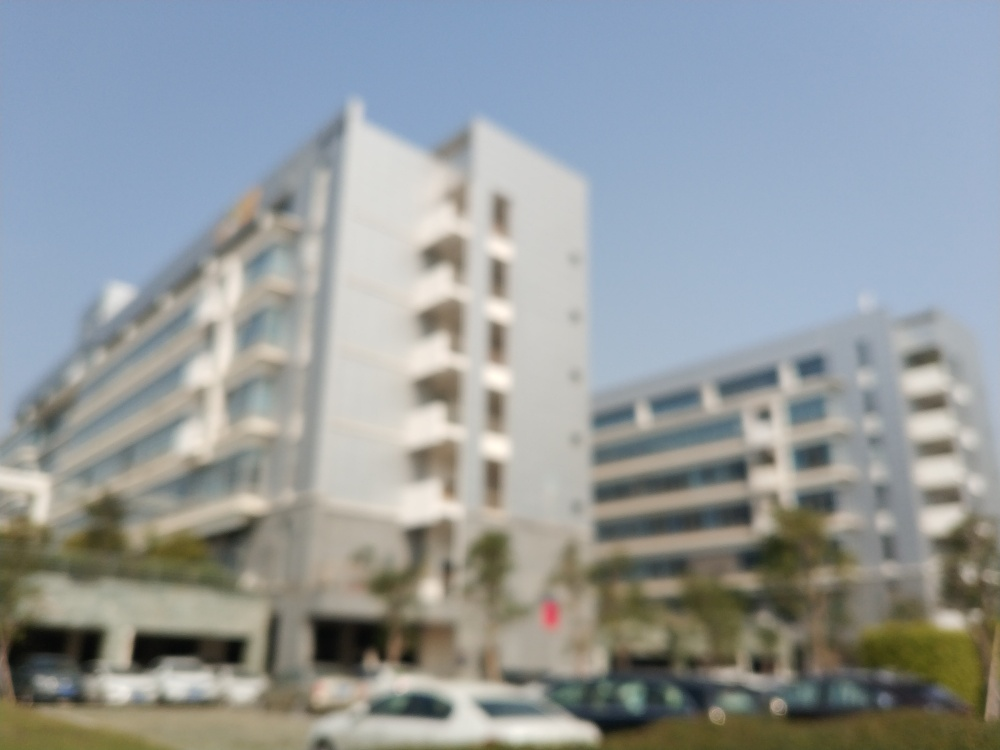What might be the reason for the blur in this image? The blur in the image could be due to several factors: a camera lens not properly focused, movement during the exposure, or a deliberate artistic choice to create a certain mood or effect. Does the blur affect the ability to identify objects in the image? Yes, the level of blur present severely impacts the ability to identify specific objects, details, or even the context of the scene. It leaves much to interpretation and can be disorienting for viewers seeking clear visual information. 